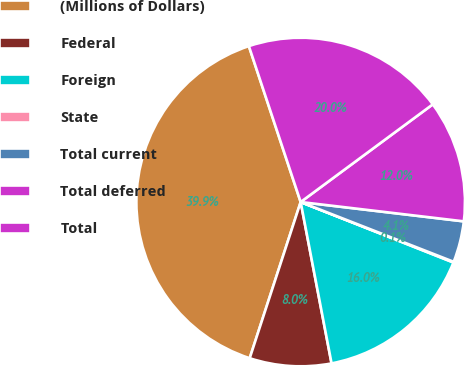Convert chart to OTSL. <chart><loc_0><loc_0><loc_500><loc_500><pie_chart><fcel>(Millions of Dollars)<fcel>Federal<fcel>Foreign<fcel>State<fcel>Total current<fcel>Total deferred<fcel>Total<nl><fcel>39.87%<fcel>8.03%<fcel>15.99%<fcel>0.07%<fcel>4.05%<fcel>12.01%<fcel>19.97%<nl></chart> 